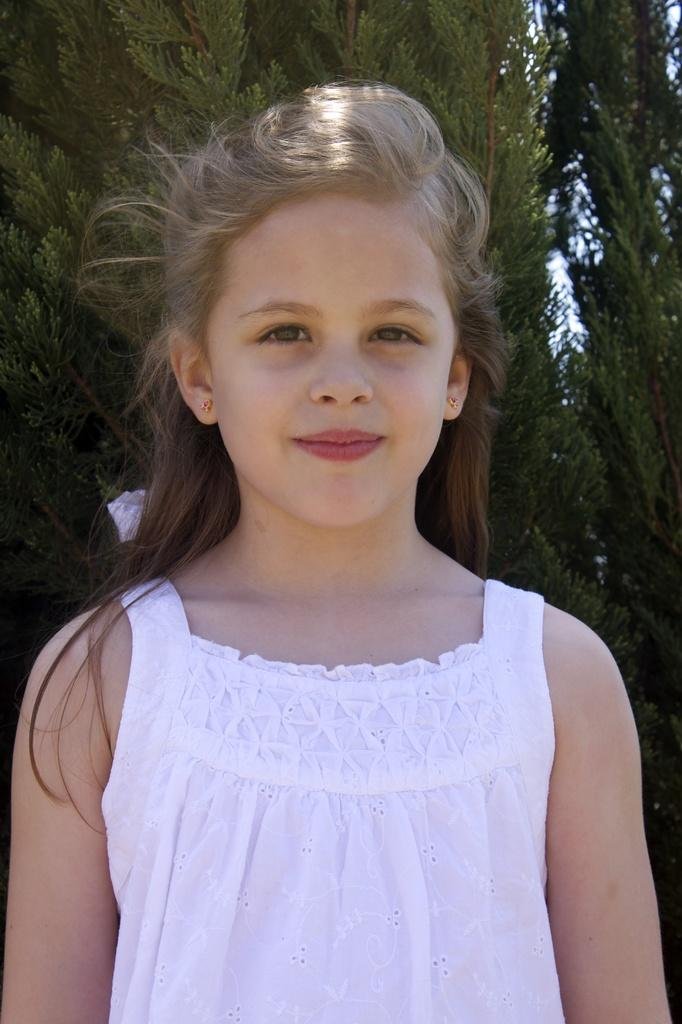Who is the main subject in the image? There is a girl in the image. What is the girl wearing? The girl is wearing a white dress. What is the girl's posture in the image? The girl is standing. What can be seen in the background of the image? There are trees and the sky visible in the background of the image. What is the color of the trees in the image? The trees are green in color. What decision does the girl make in the image? There is no indication of a decision being made in the image; the girl is simply standing and wearing a white dress. What book is the girl holding in the image? There is no book present in the image; the girl is only wearing a white dress and standing. 